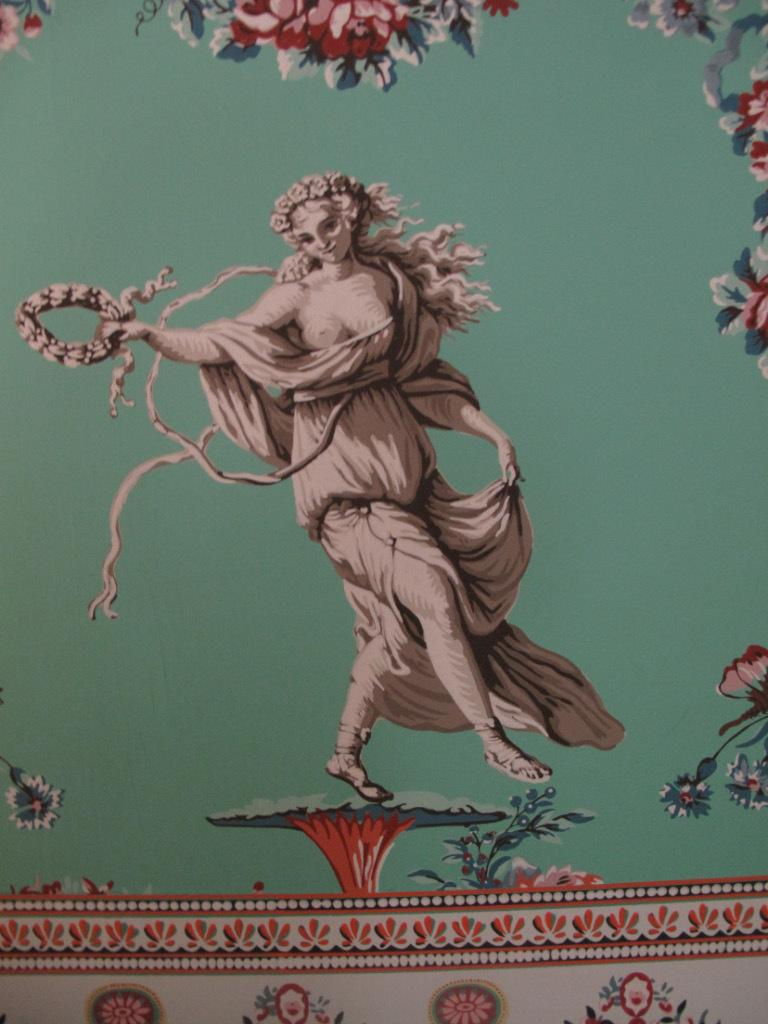What type of artwork is depicted in the image? The image is a painting. What is the human in the painting doing? The human is holding objects in the painting. What type of flora can be seen in the painting? There are flowers and leaves in the painting. What can be found at the bottom of the painting? There is a design at the bottom of the painting. What type of learning is taking place in the painting? The painting does not depict any learning activities; it simply shows a human holding objects and flora. Can you tell me how many sheep are present in the painting? There are no sheep depicted in the painting. 